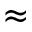Convert formula to latex. <formula><loc_0><loc_0><loc_500><loc_500>\approx</formula> 